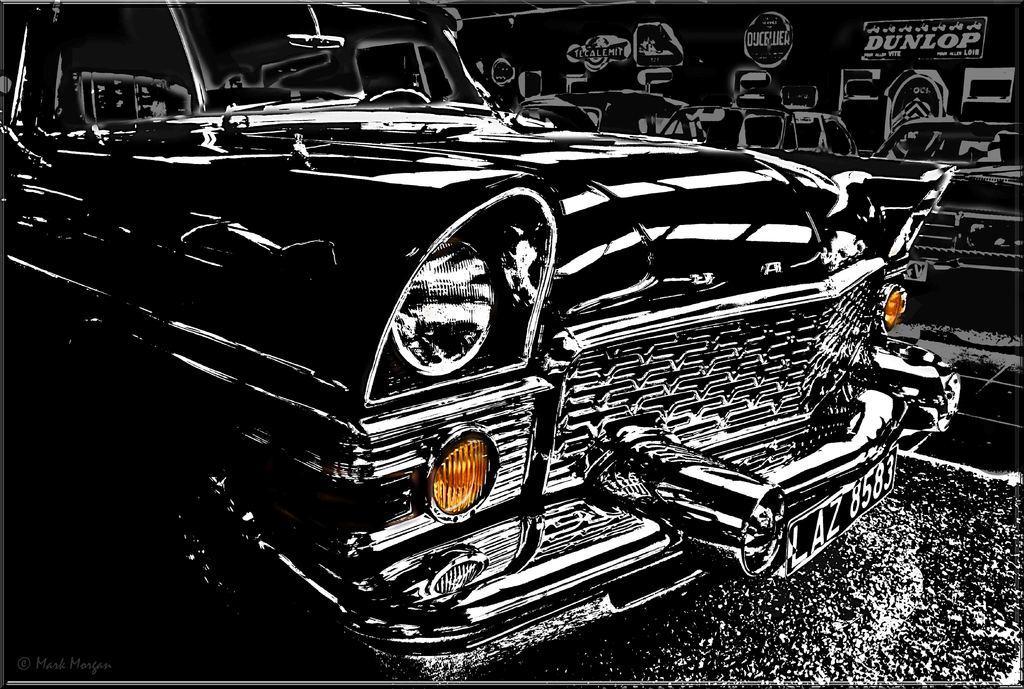Could you give a brief overview of what you see in this image? In the picture there is a drawing of a car, beside the car there is a wall, there is some text present on the wall. 